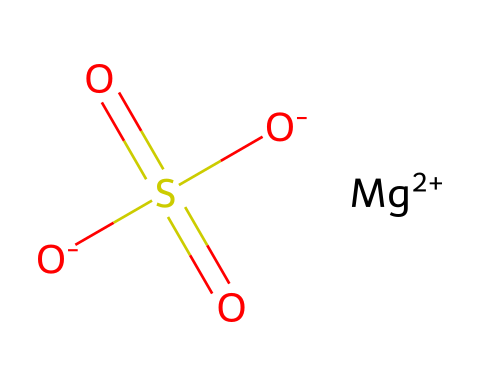What is the chemical name of this compound? The SMILES representation corresponds to magnesium sulfate, which contains magnesium, sulfur, and oxygen atoms.
Answer: magnesium sulfate How many oxygen atoms are present in this chemical? The structure indicates that there are four oxygen atoms associated with the sulfur atom and one from the magnesium ion.
Answer: four What is the charge of the magnesium ion in this structure? In the SMILES string, the magnesium ion is written as [Mg+2], indicating that it has a positive charge of +2.
Answer: +2 What is the total number of sulfate groups present? The structure contains one sulfate group (the SO4 part), which is indicated by the presence of the sulfur atom bonded to four oxygen atoms.
Answer: one What type of electrolyte does magnesium sulfate represent? Magnesium sulfate is classified as a type of inorganic electrolyte based on its composition and the presence of ions in solution that facilitate electrical conduction.
Answer: inorganic How many sulfur atoms can be found in this chemical? There is one sulfur atom in the structure, as indicated by the sulfur letter 'S' in the SMILES representation.
Answer: one 